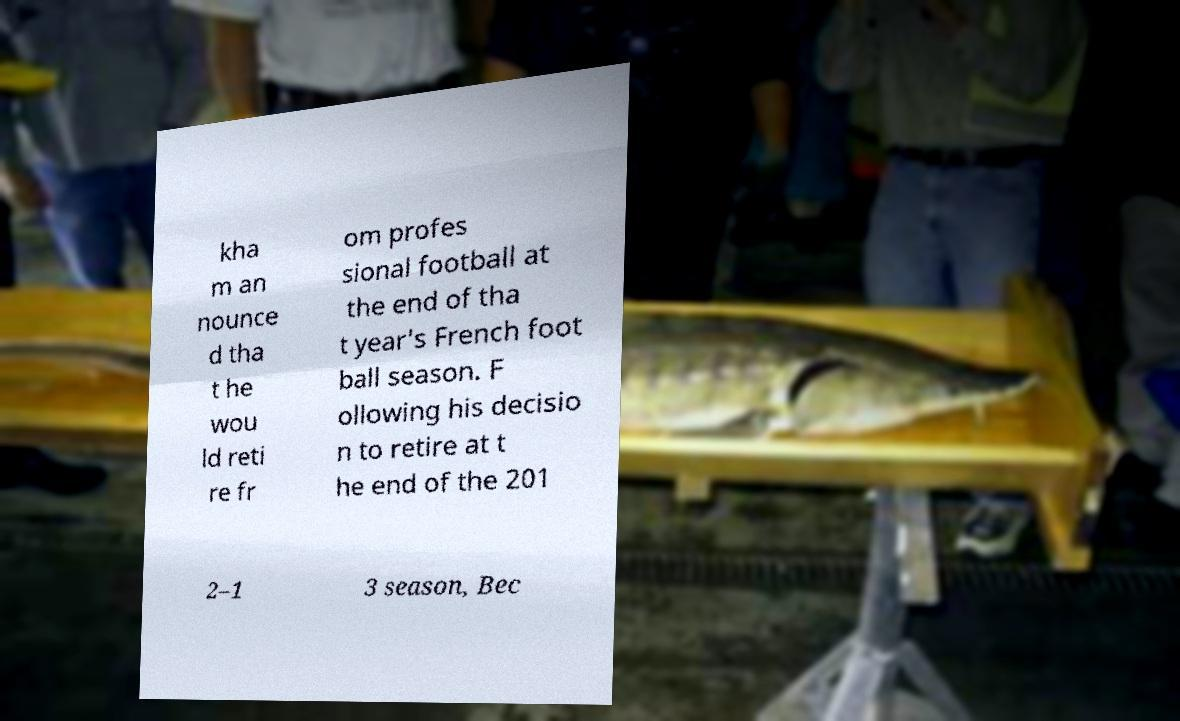For documentation purposes, I need the text within this image transcribed. Could you provide that? kha m an nounce d tha t he wou ld reti re fr om profes sional football at the end of tha t year's French foot ball season. F ollowing his decisio n to retire at t he end of the 201 2–1 3 season, Bec 